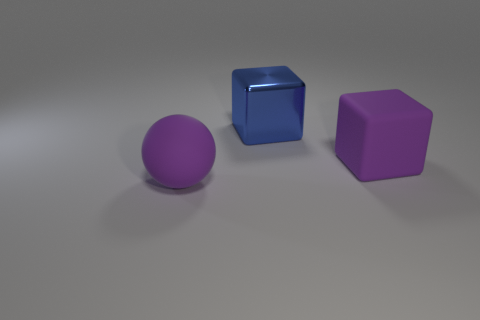Add 3 big rubber objects. How many objects exist? 6 Subtract all blocks. How many objects are left? 1 Add 3 metal blocks. How many metal blocks are left? 4 Add 1 blue cubes. How many blue cubes exist? 2 Subtract 0 cyan cylinders. How many objects are left? 3 Subtract all big red metal balls. Subtract all blocks. How many objects are left? 1 